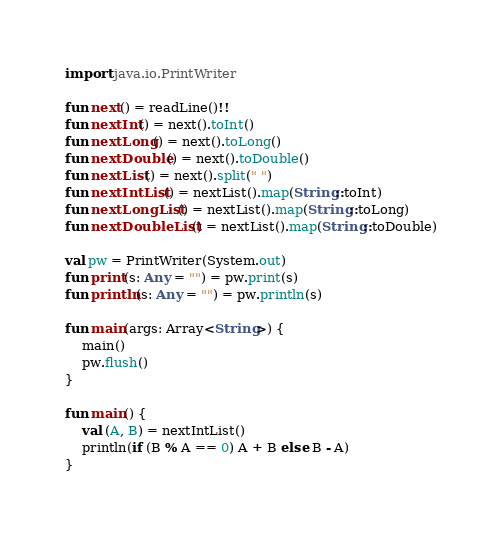Convert code to text. <code><loc_0><loc_0><loc_500><loc_500><_Kotlin_>import java.io.PrintWriter

fun next() = readLine()!!
fun nextInt() = next().toInt()
fun nextLong() = next().toLong()
fun nextDouble() = next().toDouble()
fun nextList() = next().split(" ")
fun nextIntList() = nextList().map(String::toInt)
fun nextLongList() = nextList().map(String::toLong)
fun nextDoubleList() = nextList().map(String::toDouble)

val pw = PrintWriter(System.out)
fun print(s: Any = "") = pw.print(s)
fun println(s: Any = "") = pw.println(s)

fun main(args: Array<String>) {
    main()
    pw.flush()
}

fun main() {
    val (A, B) = nextIntList()
    println(if (B % A == 0) A + B else B - A)
}</code> 